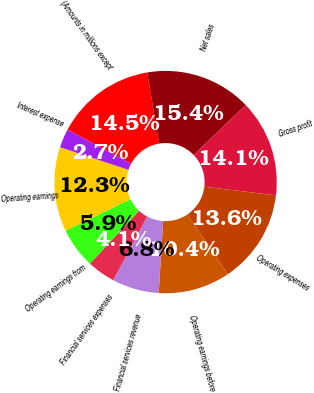<chart> <loc_0><loc_0><loc_500><loc_500><pie_chart><fcel>(Amounts in millions except<fcel>Net sales<fcel>Gross profit<fcel>Operating expenses<fcel>Operating earnings before<fcel>Financial services revenue<fcel>Financial services expenses<fcel>Operating earnings from<fcel>Operating earnings<fcel>Interest expense<nl><fcel>14.55%<fcel>15.45%<fcel>14.09%<fcel>13.64%<fcel>10.45%<fcel>6.82%<fcel>4.09%<fcel>5.91%<fcel>12.27%<fcel>2.73%<nl></chart> 